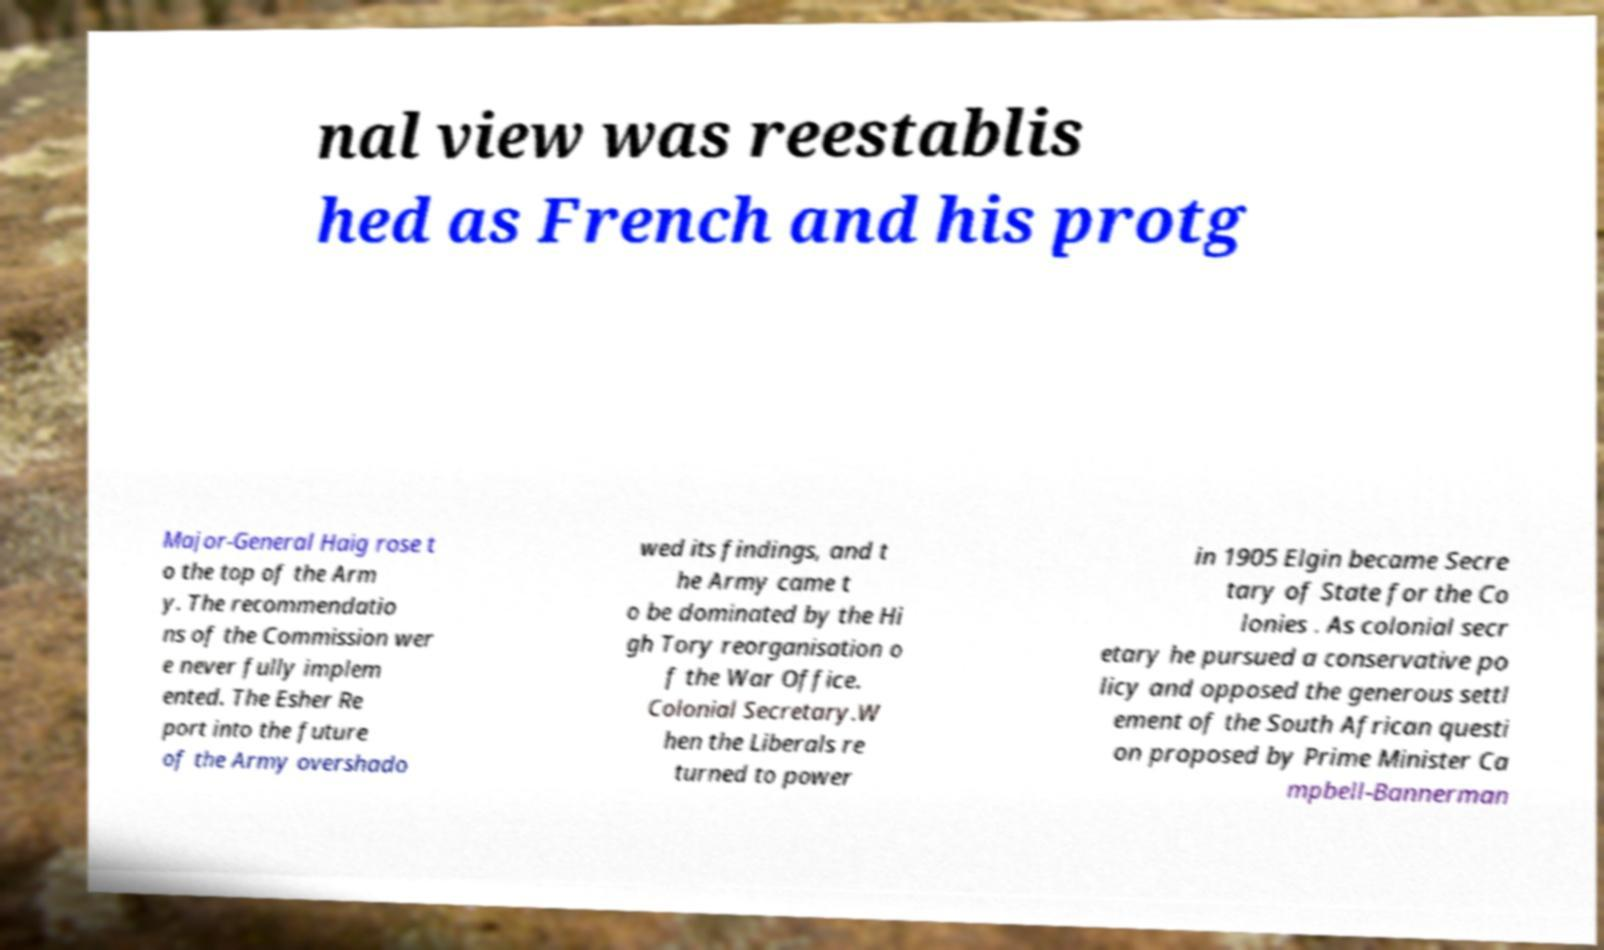There's text embedded in this image that I need extracted. Can you transcribe it verbatim? nal view was reestablis hed as French and his protg Major-General Haig rose t o the top of the Arm y. The recommendatio ns of the Commission wer e never fully implem ented. The Esher Re port into the future of the Army overshado wed its findings, and t he Army came t o be dominated by the Hi gh Tory reorganisation o f the War Office. Colonial Secretary.W hen the Liberals re turned to power in 1905 Elgin became Secre tary of State for the Co lonies . As colonial secr etary he pursued a conservative po licy and opposed the generous settl ement of the South African questi on proposed by Prime Minister Ca mpbell-Bannerman 